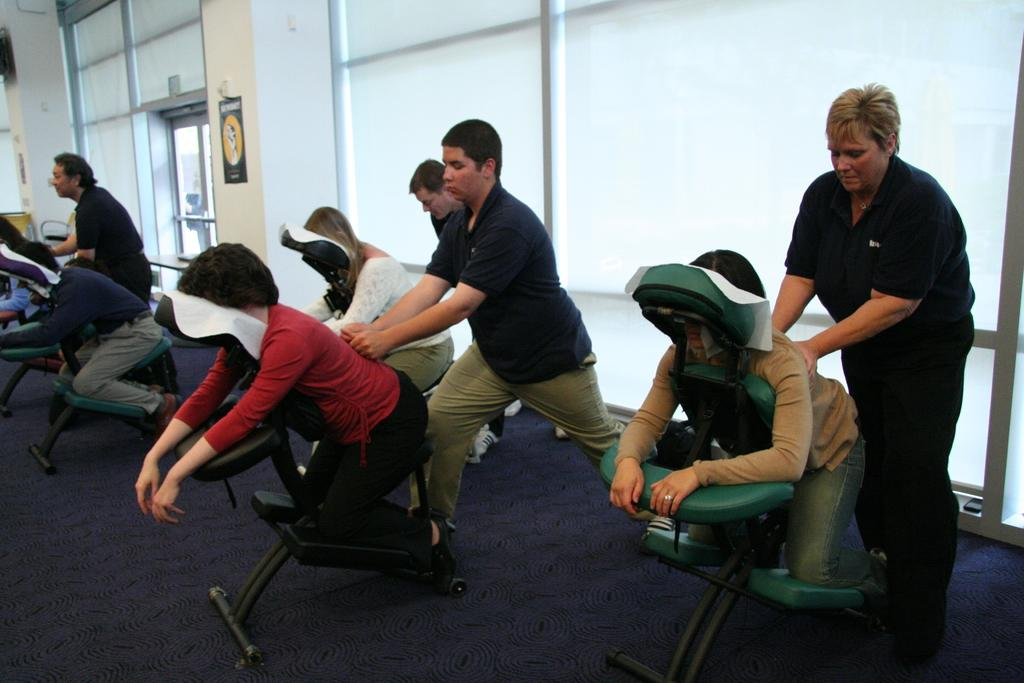What activity are the people in the image engaged in? The people in the image are receiving massage therapy. What can be seen in the background of the image? There are many windows visible in the background. Are there any architectural features between the windows? Yes, there are two pillars between the windows. What type of rabbit can be seen hopping on the ground in the image? There is no rabbit present in the image; it features people receiving massage therapy and windows in the background. 